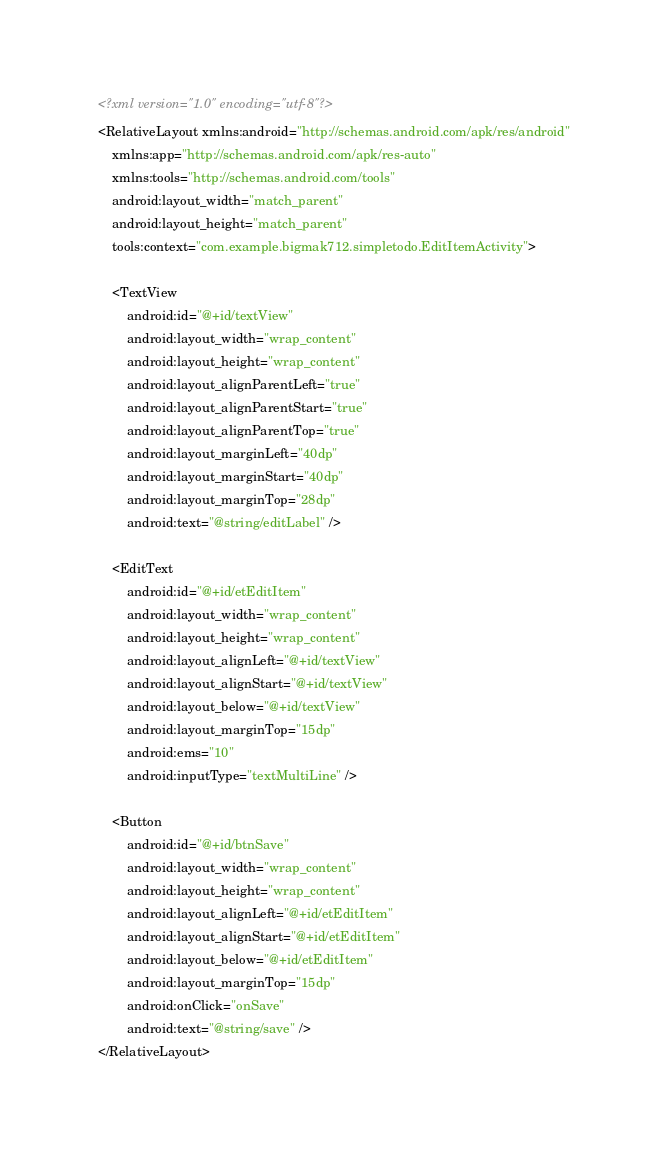Convert code to text. <code><loc_0><loc_0><loc_500><loc_500><_XML_><?xml version="1.0" encoding="utf-8"?>
<RelativeLayout xmlns:android="http://schemas.android.com/apk/res/android"
    xmlns:app="http://schemas.android.com/apk/res-auto"
    xmlns:tools="http://schemas.android.com/tools"
    android:layout_width="match_parent"
    android:layout_height="match_parent"
    tools:context="com.example.bigmak712.simpletodo.EditItemActivity">

    <TextView
        android:id="@+id/textView"
        android:layout_width="wrap_content"
        android:layout_height="wrap_content"
        android:layout_alignParentLeft="true"
        android:layout_alignParentStart="true"
        android:layout_alignParentTop="true"
        android:layout_marginLeft="40dp"
        android:layout_marginStart="40dp"
        android:layout_marginTop="28dp"
        android:text="@string/editLabel" />

    <EditText
        android:id="@+id/etEditItem"
        android:layout_width="wrap_content"
        android:layout_height="wrap_content"
        android:layout_alignLeft="@+id/textView"
        android:layout_alignStart="@+id/textView"
        android:layout_below="@+id/textView"
        android:layout_marginTop="15dp"
        android:ems="10"
        android:inputType="textMultiLine" />

    <Button
        android:id="@+id/btnSave"
        android:layout_width="wrap_content"
        android:layout_height="wrap_content"
        android:layout_alignLeft="@+id/etEditItem"
        android:layout_alignStart="@+id/etEditItem"
        android:layout_below="@+id/etEditItem"
        android:layout_marginTop="15dp"
        android:onClick="onSave"
        android:text="@string/save" />
</RelativeLayout>
</code> 